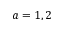Convert formula to latex. <formula><loc_0><loc_0><loc_500><loc_500>a = 1 , 2</formula> 